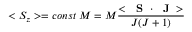<formula> <loc_0><loc_0><loc_500><loc_500>< S _ { z } > = c o n s t \, M = M \frac { < S \cdot J > } { J ( J + 1 ) }</formula> 